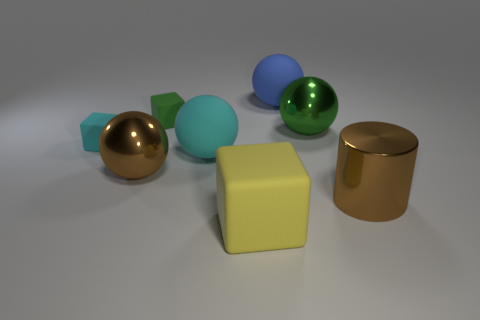Add 1 brown matte cubes. How many objects exist? 9 Subtract all cubes. How many objects are left? 5 Subtract 0 blue cylinders. How many objects are left? 8 Subtract all brown metallic balls. Subtract all cyan blocks. How many objects are left? 6 Add 5 large brown metal cylinders. How many large brown metal cylinders are left? 6 Add 2 small yellow matte cylinders. How many small yellow matte cylinders exist? 2 